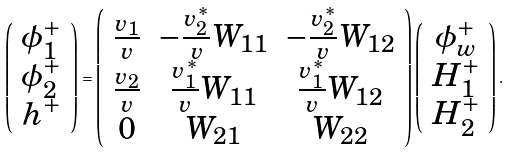<formula> <loc_0><loc_0><loc_500><loc_500>\left ( \begin{array} { c } { { \phi _ { 1 } ^ { + } } } \\ { { \phi _ { 2 } ^ { + } } } \\ { { h ^ { + } } } \end{array} \right ) = \left ( \begin{array} { c c c } { { \frac { v _ { 1 } } { v } } } & { { - \frac { v _ { 2 } ^ { * } } { v } W _ { 1 1 } } } & { { - \frac { v _ { 2 } ^ { * } } { v } W _ { 1 2 } } } \\ { { \frac { v _ { 2 } } { v } } } & { { \frac { v _ { 1 } ^ { * } } { v } W _ { 1 1 } } } & { { \frac { v _ { 1 } ^ { * } } { v } W _ { 1 2 } } } \\ { 0 } & { { W _ { 2 1 } } } & { { W _ { 2 2 } } } \end{array} \right ) \left ( \begin{array} { c } { { \phi _ { w } ^ { + } } } \\ { { H _ { 1 } ^ { + } } } \\ { { H _ { 2 } ^ { + } } } \end{array} \right ) .</formula> 